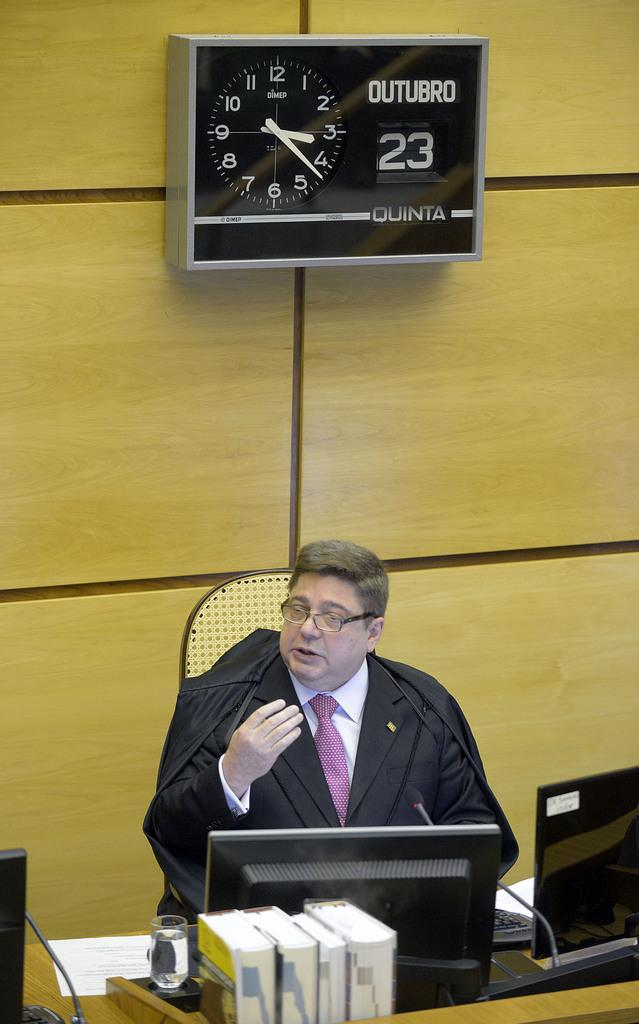<image>
Share a concise interpretation of the image provided. A clock that says Outubro on it states that the date is the 23rd. 